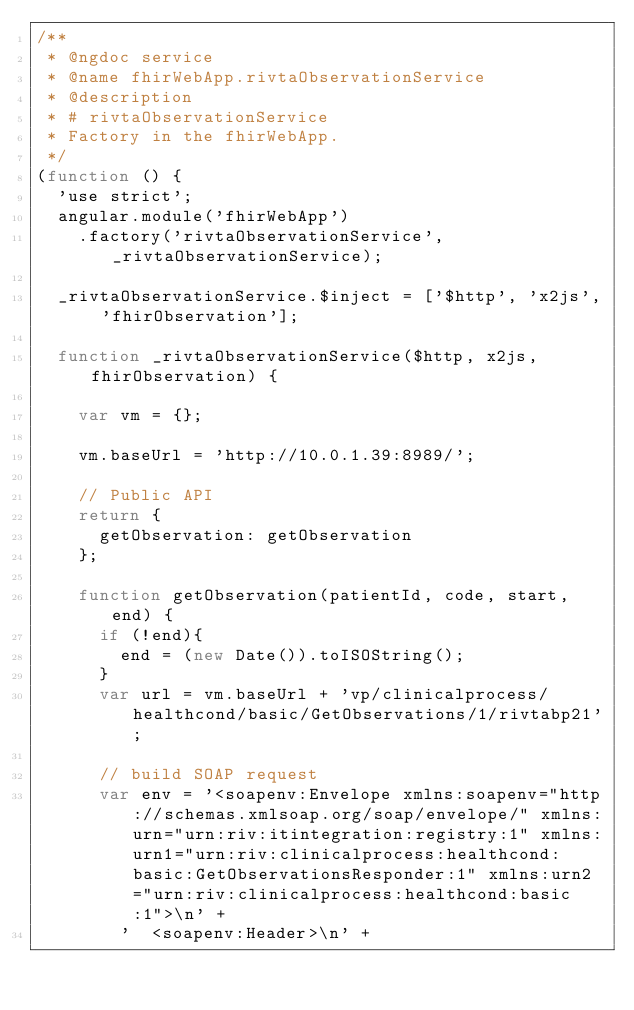<code> <loc_0><loc_0><loc_500><loc_500><_JavaScript_>/**
 * @ngdoc service
 * @name fhirWebApp.rivtaObservationService
 * @description
 * # rivtaObservationService
 * Factory in the fhirWebApp.
 */
(function () {
  'use strict';
  angular.module('fhirWebApp')
    .factory('rivtaObservationService', _rivtaObservationService);

  _rivtaObservationService.$inject = ['$http', 'x2js', 'fhirObservation'];

  function _rivtaObservationService($http, x2js, fhirObservation) {

    var vm = {};

    vm.baseUrl = 'http://10.0.1.39:8989/';

    // Public API
    return {
      getObservation: getObservation
    };

    function getObservation(patientId, code, start, end) {
      if (!end){
        end = (new Date()).toISOString();
      }
      var url = vm.baseUrl + 'vp/clinicalprocess/healthcond/basic/GetObservations/1/rivtabp21';

      // build SOAP request
      var env = '<soapenv:Envelope xmlns:soapenv="http://schemas.xmlsoap.org/soap/envelope/" xmlns:urn="urn:riv:itintegration:registry:1" xmlns:urn1="urn:riv:clinicalprocess:healthcond:basic:GetObservationsResponder:1" xmlns:urn2="urn:riv:clinicalprocess:healthcond:basic:1">\n' +
        '  <soapenv:Header>\n' +</code> 